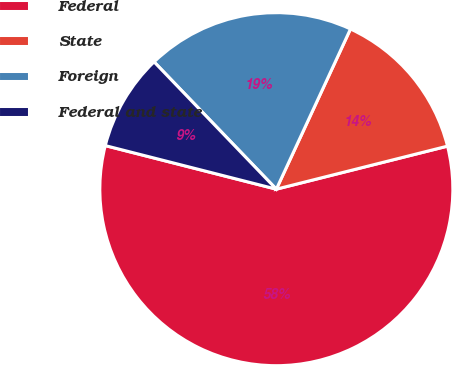Convert chart to OTSL. <chart><loc_0><loc_0><loc_500><loc_500><pie_chart><fcel>Federal<fcel>State<fcel>Foreign<fcel>Federal and state<nl><fcel>57.89%<fcel>14.18%<fcel>19.08%<fcel>8.85%<nl></chart> 